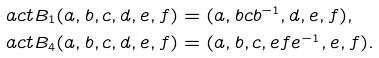<formula> <loc_0><loc_0><loc_500><loc_500>\ a c t B _ { 1 } ( a , b , c , d , e , f ) & = ( a , b c b ^ { - 1 } , d , e , f ) , \\ \ a c t B _ { 4 } ( a , b , c , d , e , f ) & = ( a , b , c , e f e ^ { - 1 } , e , f ) .</formula> 